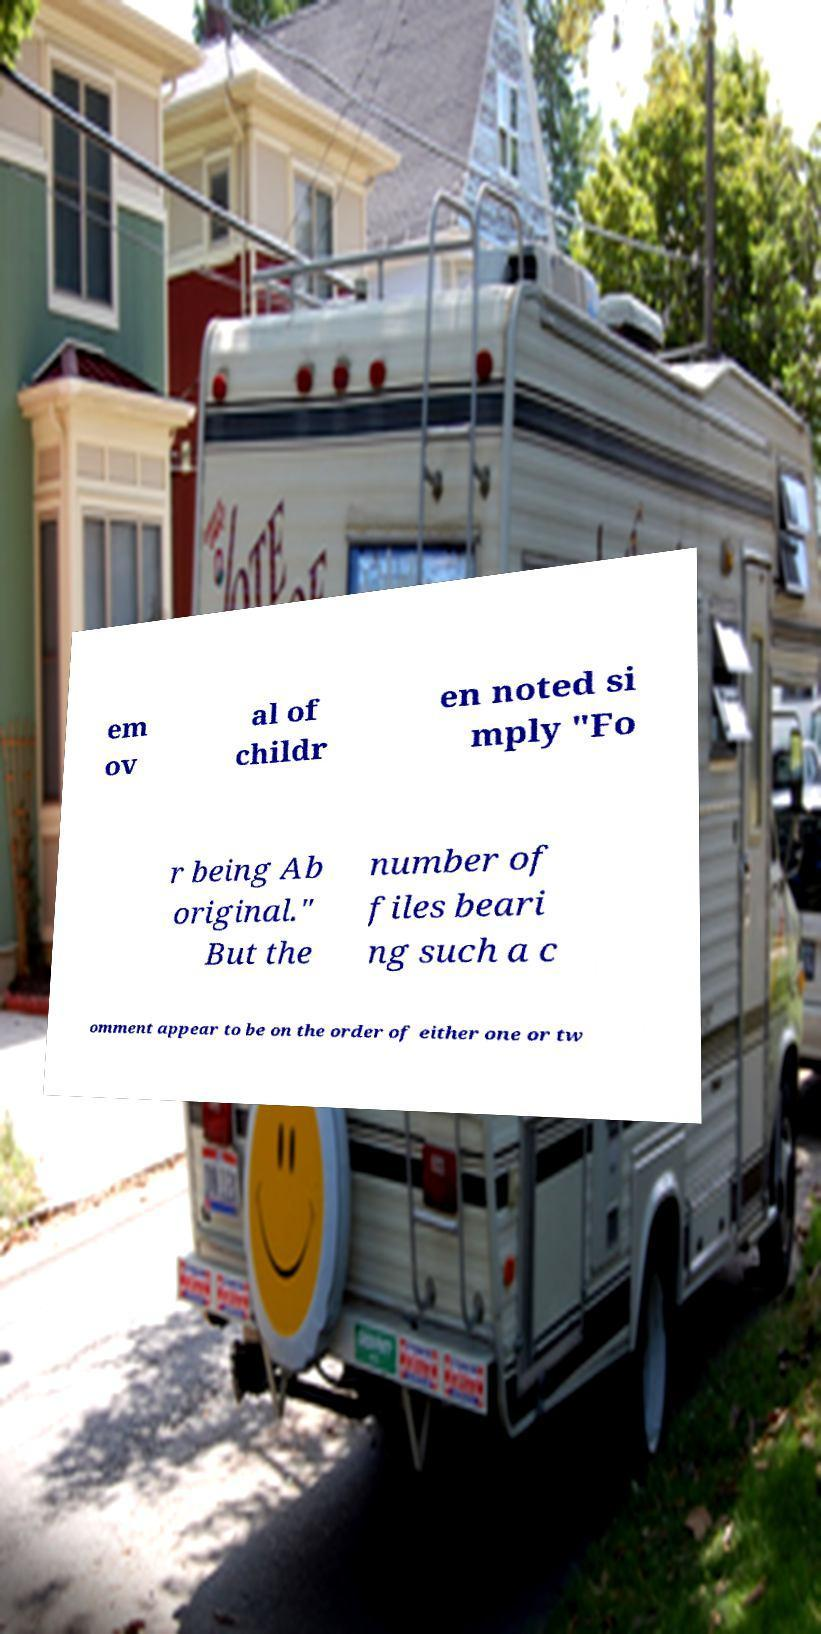For documentation purposes, I need the text within this image transcribed. Could you provide that? em ov al of childr en noted si mply "Fo r being Ab original." But the number of files beari ng such a c omment appear to be on the order of either one or tw 